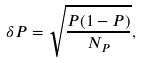<formula> <loc_0><loc_0><loc_500><loc_500>\delta P = \sqrt { \frac { P ( 1 - P ) } { N _ { P } } } ,</formula> 